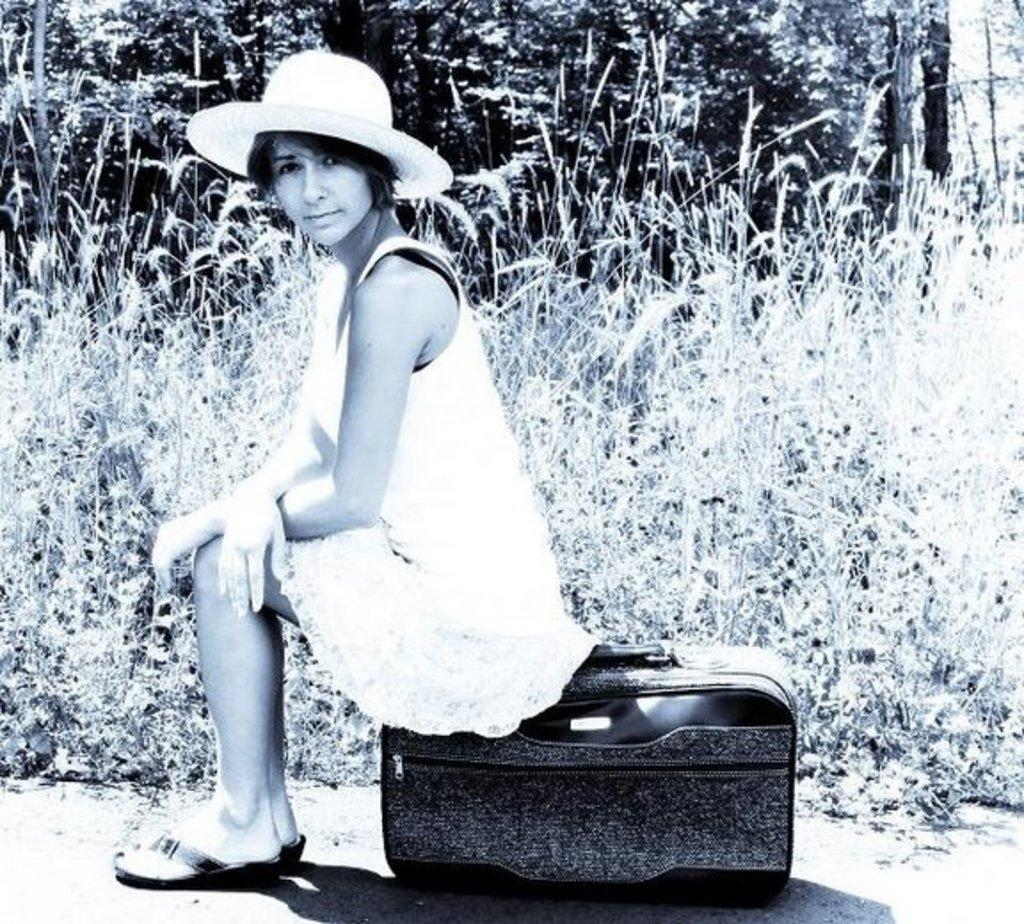Who is the main subject in the image? There is a lady in the center of the image. What is the lady sitting on? The lady is sitting on a briefcase. What is the lady wearing? The lady is wearing a white dress and a hat. What can be seen in the background of the image? There is grass and trees in the background of the image. What type of oatmeal is the lady holding in her pocket? There is no oatmeal present in the image, and the lady is not holding anything in her pocket. 